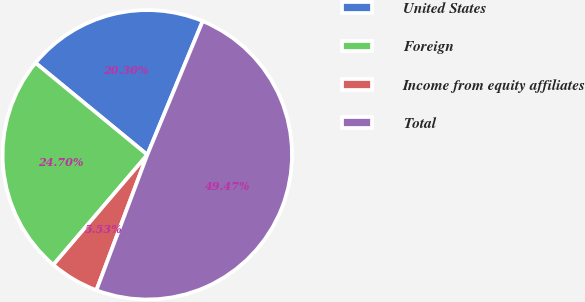<chart> <loc_0><loc_0><loc_500><loc_500><pie_chart><fcel>United States<fcel>Foreign<fcel>Income from equity affiliates<fcel>Total<nl><fcel>20.3%<fcel>24.7%<fcel>5.53%<fcel>49.47%<nl></chart> 